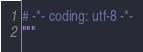Convert code to text. <code><loc_0><loc_0><loc_500><loc_500><_Python_># -*- coding: utf-8 -*-
"""</code> 